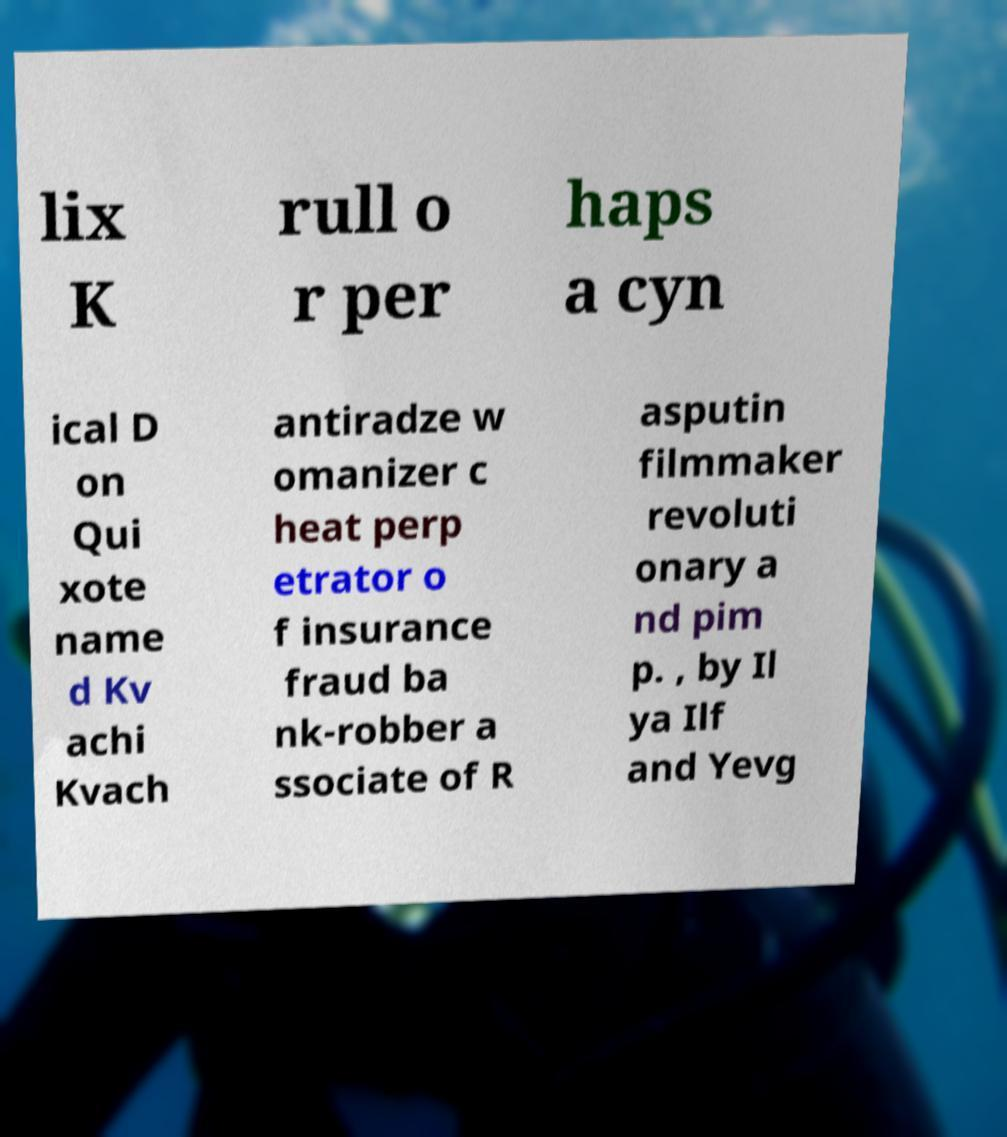Please identify and transcribe the text found in this image. lix K rull o r per haps a cyn ical D on Qui xote name d Kv achi Kvach antiradze w omanizer c heat perp etrator o f insurance fraud ba nk-robber a ssociate of R asputin filmmaker revoluti onary a nd pim p. , by Il ya Ilf and Yevg 